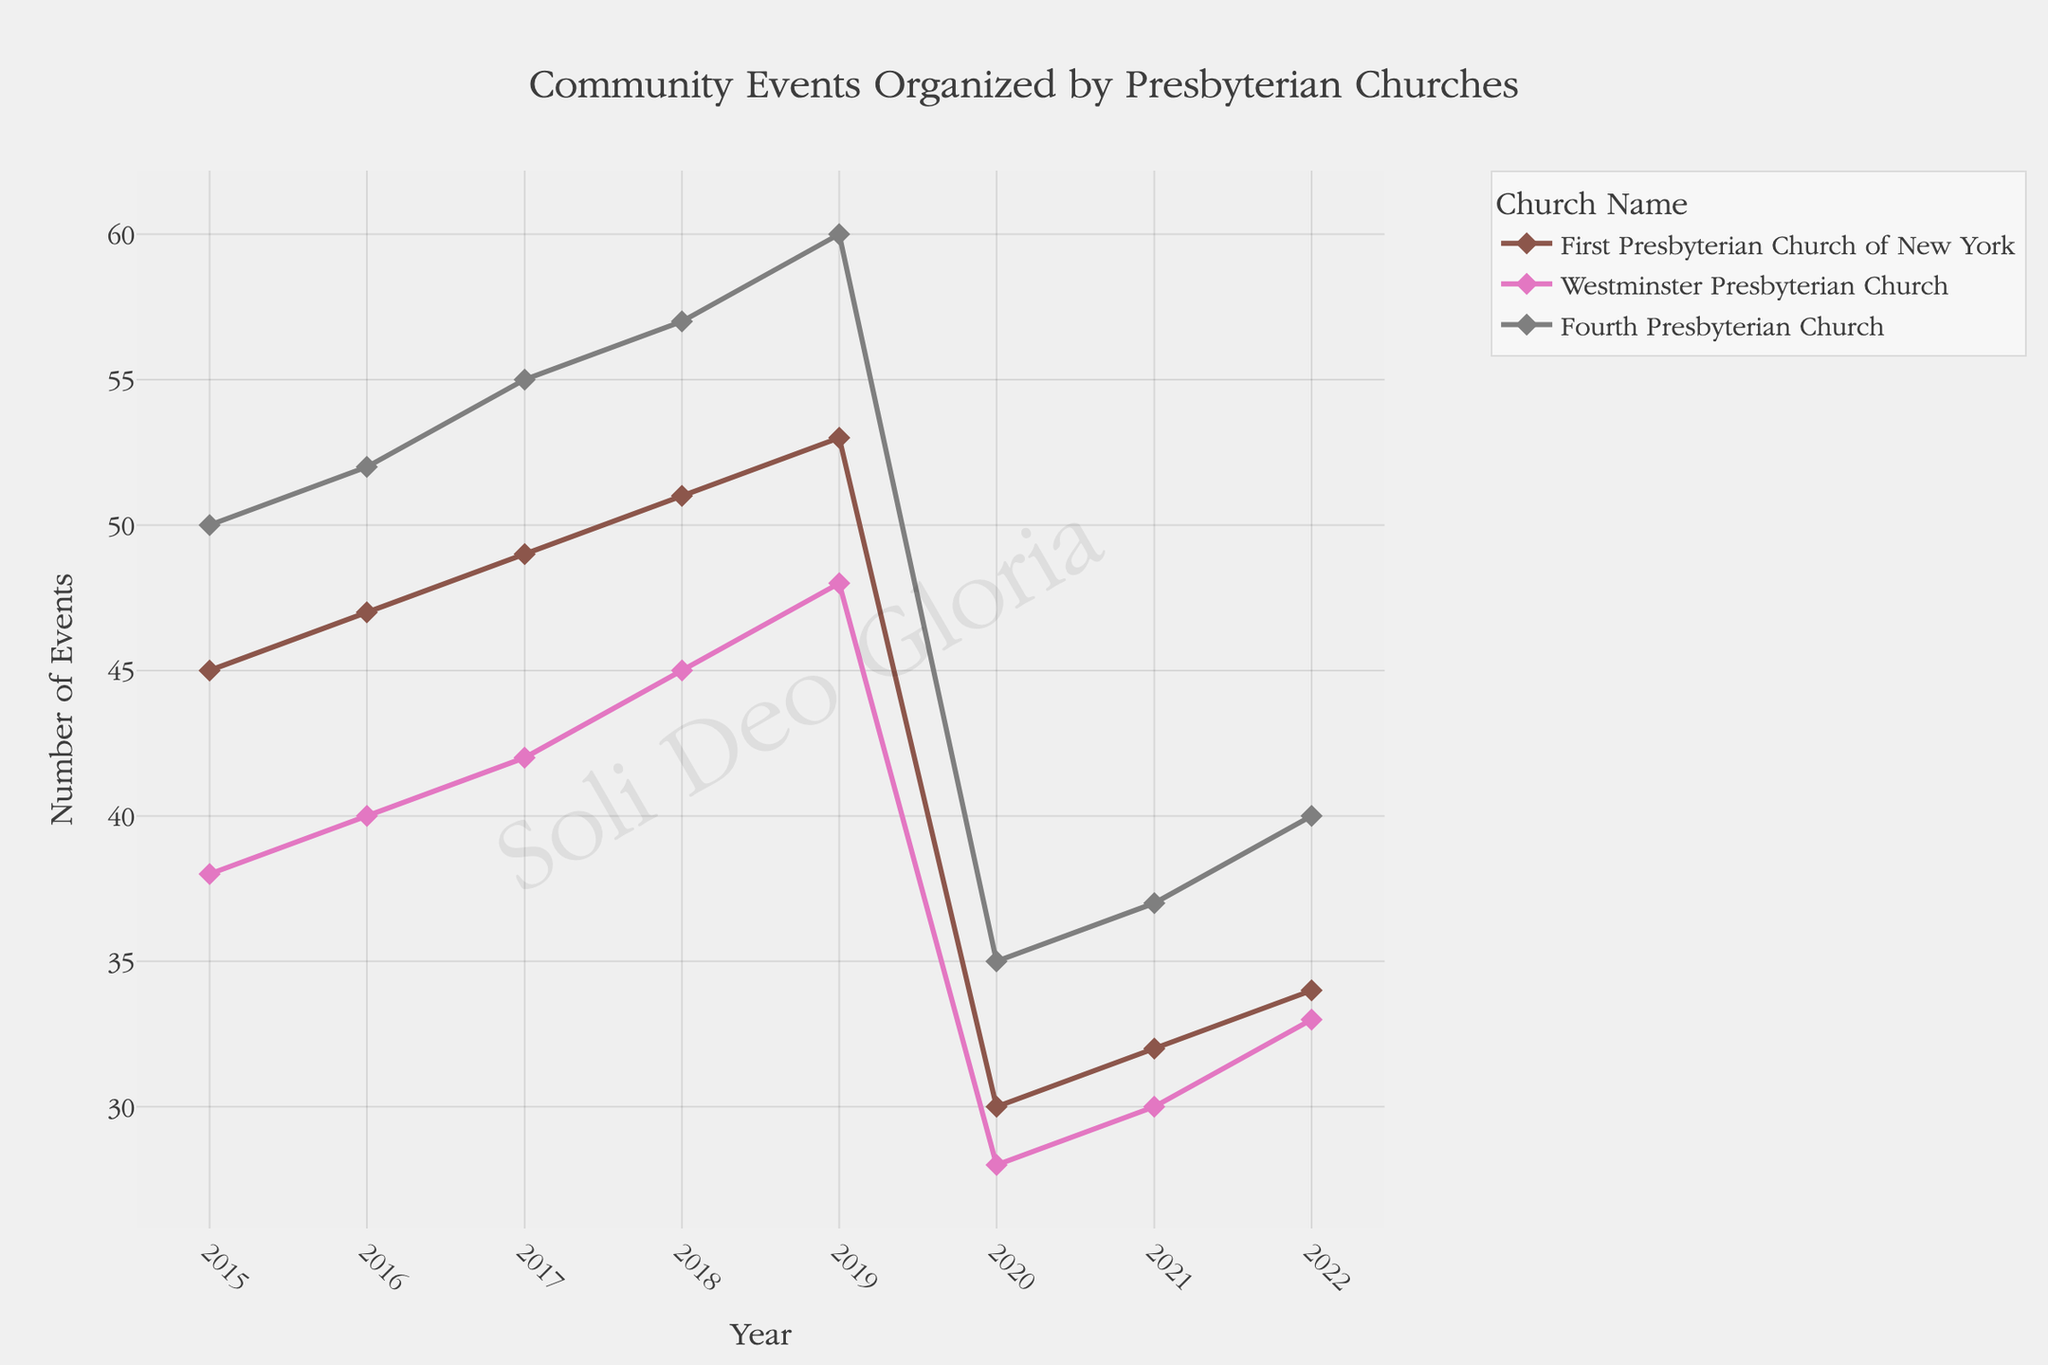How many events did the First Presbyterian Church of New York organize in 2020? Referring directly to the data, find the value for the First Presbyterian Church of New York in the year 2020. The number of events organized was 30.
Answer: 30 Which church organized the most community events in 2019? Review all the churches' event counts in 2019. The Fourth Presbyterian Church had 60 events, which is the highest number compared to the other two churches.
Answer: Fourth Presbyterian Church What is the trend of community events organized from 2015 to 2019 for the Westminster Presbyterian Church? Look at the data points for the Westminster Presbyterian Church from 2015 to 2019. The counts are 38, 40, 42, 45, and 48, respectively. This shows a consistent upward trend each year.
Answer: Increasing trend What is the average number of events organized by the Fourth Presbyterian Church from 2015 to 2019? Sum the number of events for the Fourth Presbyterian Church from 2015 to 2019 and then divide by the number of years. (50 + 52 + 55 + 57 + 60) = 274. Divide by 5 gives an average of 54.8.
Answer: 54.8 Which year showed a significant drop in community events organized by all the churches? Observing the trend lines for all churches, note any year where there is a noticeable drop. In 2020, each church shows a significant decrease in the number of events organized.
Answer: 2020 Did the number of events organized by First Presbyterian Church of New York increase or decrease from 2021 to 2022? Compare the event counts for the First Presbyterian Church of New York for 2021 and 2022. It increased from 32 events in 2021 to 34 events in 2022.
Answer: Increase What is the cumulative number of events organized by all churches in 2017? Add the event counts from all three churches for the year 2017: 49 (First Presbyterian Church of New York) + 42 (Westminster Presbyterian Church) + 55 (Fourth Presbyterian Church). The sum is 146.
Answer: 146 Which church showed the greatest variation in the number of events organized from 2015 to 2022? To find the greatest variation, assess the range (maximum - minimum) of events for each church from 2015 to 2022. First Presbyterian Church of New York ranges from 30 to 53 (range of 23), Westminster Presbyterian Church from 28 to 48 (range of 20), and Fourth Presbyterian Church from 35 to 60 (range of 25). The Fourth Presbyterian Church shows the greatest variation.
Answer: Fourth Presbyterian Church What are the overall trends in community event organizing after 2019 for all the churches? Examine the trend lines for the years after 2019 (2020, 2021, 2022). All churches show a significant decline in events in 2020, with slight increases or stability in 2021 and 2022.
Answer: Decline after 2019 